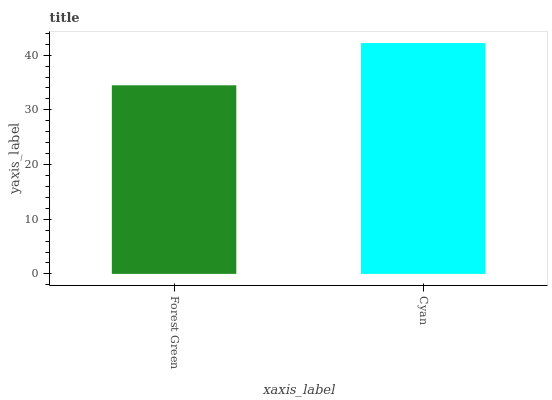Is Forest Green the minimum?
Answer yes or no. Yes. Is Cyan the maximum?
Answer yes or no. Yes. Is Cyan the minimum?
Answer yes or no. No. Is Cyan greater than Forest Green?
Answer yes or no. Yes. Is Forest Green less than Cyan?
Answer yes or no. Yes. Is Forest Green greater than Cyan?
Answer yes or no. No. Is Cyan less than Forest Green?
Answer yes or no. No. Is Cyan the high median?
Answer yes or no. Yes. Is Forest Green the low median?
Answer yes or no. Yes. Is Forest Green the high median?
Answer yes or no. No. Is Cyan the low median?
Answer yes or no. No. 